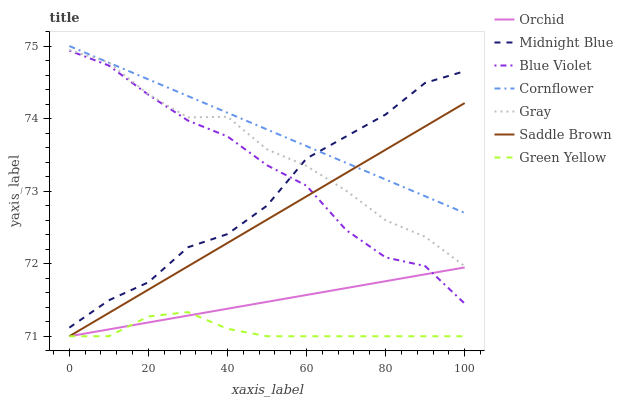Does Green Yellow have the minimum area under the curve?
Answer yes or no. Yes. Does Cornflower have the maximum area under the curve?
Answer yes or no. Yes. Does Midnight Blue have the minimum area under the curve?
Answer yes or no. No. Does Midnight Blue have the maximum area under the curve?
Answer yes or no. No. Is Orchid the smoothest?
Answer yes or no. Yes. Is Gray the roughest?
Answer yes or no. Yes. Is Midnight Blue the smoothest?
Answer yes or no. No. Is Midnight Blue the roughest?
Answer yes or no. No. Does Green Yellow have the lowest value?
Answer yes or no. Yes. Does Midnight Blue have the lowest value?
Answer yes or no. No. Does Cornflower have the highest value?
Answer yes or no. Yes. Does Midnight Blue have the highest value?
Answer yes or no. No. Is Saddle Brown less than Midnight Blue?
Answer yes or no. Yes. Is Midnight Blue greater than Saddle Brown?
Answer yes or no. Yes. Does Saddle Brown intersect Green Yellow?
Answer yes or no. Yes. Is Saddle Brown less than Green Yellow?
Answer yes or no. No. Is Saddle Brown greater than Green Yellow?
Answer yes or no. No. Does Saddle Brown intersect Midnight Blue?
Answer yes or no. No. 